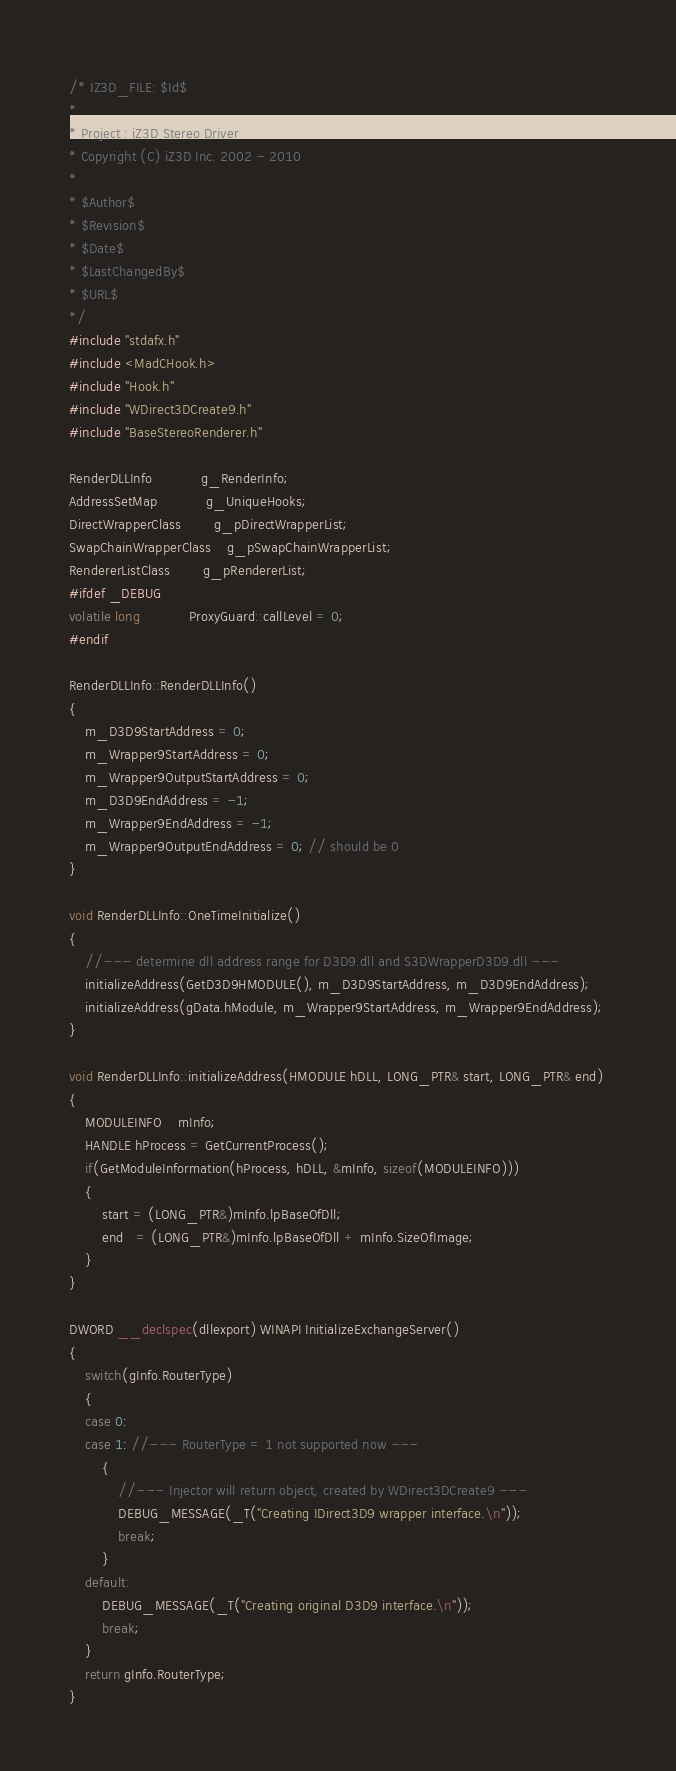Convert code to text. <code><loc_0><loc_0><loc_500><loc_500><_C++_>/* IZ3D_FILE: $Id$ 
*
* Project : iZ3D Stereo Driver
* Copyright (C) iZ3D Inc. 2002 - 2010
*
* $Author$
* $Revision$
* $Date$
* $LastChangedBy$
* $URL$
*/
#include "stdafx.h"
#include <MadCHook.h>
#include "Hook.h"
#include "WDirect3DCreate9.h"
#include "BaseStereoRenderer.h"

RenderDLLInfo			g_RenderInfo;
AddressSetMap			g_UniqueHooks;
DirectWrapperClass		g_pDirectWrapperList;
SwapChainWrapperClass	g_pSwapChainWrapperList;
RendererListClass		g_pRendererList;
#ifdef _DEBUG
volatile long			ProxyGuard::callLevel = 0;
#endif

RenderDLLInfo::RenderDLLInfo()
{
	m_D3D9StartAddress = 0;
	m_Wrapper9StartAddress = 0;
	m_Wrapper9OutputStartAddress = 0;
	m_D3D9EndAddress = -1;
	m_Wrapper9EndAddress = -1; 
	m_Wrapper9OutputEndAddress = 0; // should be 0
}

void RenderDLLInfo::OneTimeInitialize()
{
	//--- determine dll address range for D3D9.dll and S3DWrapperD3D9.dll ---
	initializeAddress(GetD3D9HMODULE(), m_D3D9StartAddress, m_D3D9EndAddress); 
	initializeAddress(gData.hModule, m_Wrapper9StartAddress, m_Wrapper9EndAddress); 
}

void RenderDLLInfo::initializeAddress(HMODULE hDLL, LONG_PTR& start, LONG_PTR& end)
{
	MODULEINFO	mInfo;
	HANDLE hProcess = GetCurrentProcess();
	if(GetModuleInformation(hProcess, hDLL, &mInfo, sizeof(MODULEINFO)))
	{
		start = (LONG_PTR&)mInfo.lpBaseOfDll;
		end   = (LONG_PTR&)mInfo.lpBaseOfDll + mInfo.SizeOfImage;
	}
}

DWORD __declspec(dllexport) WINAPI InitializeExchangeServer()
{
	switch(gInfo.RouterType)
	{
	case 0:
	case 1: //--- RouterType = 1 not supported now ---
		{
			//--- Injector will return object, created by WDirect3DCreate9 ---
			DEBUG_MESSAGE(_T("Creating IDirect3D9 wrapper interface.\n"));
			break;
		}
	default:
		DEBUG_MESSAGE(_T("Creating original D3D9 interface.\n"));
		break;
	}
	return gInfo.RouterType; 
}
</code> 